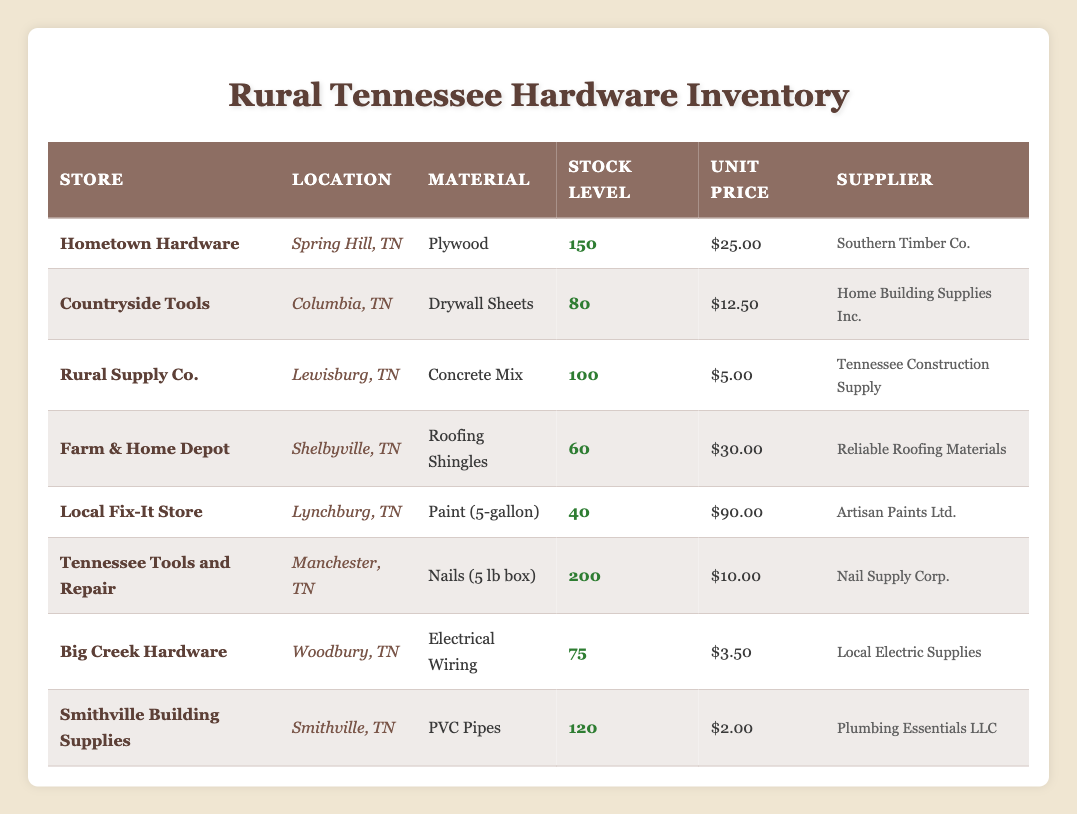What is the stock level of ""Plywood"" at Hometown Hardware? Hometown Hardware has a stock level of 150 for Plywood as listed in the inventory table.
Answer: 150 Which store has the highest stock level of home repair materials? Tennessee Tools and Repair has the highest stock level at 200, for Nails (5 lb box).
Answer: Tennessee Tools and Repair What is the total stock level of Concrete Mix and Drywall Sheets combined? Concrete Mix has a stock level of 100 and Drywall Sheets has a stock level of 80. Adding them gives 100 + 80 = 180.
Answer: 180 Is Local Fix-It Store the supplier for any paint? The Local Fix-It Store sells Paint (5-gallon), which is listed in the inventory. Therefore, the statement is true.
Answer: Yes Which material has the lowest stock level and what is that stock level? Among all materials, Paint (5-gallon) has the lowest stock level at 40.
Answer: 40 How much does it cost to buy the total stock of Electrical Wiring? The stock level for Electrical Wiring is 75 and the unit price is 3.50. The total cost is calculated as 75 * 3.50 = 262.50.
Answer: 262.50 What is the average unit price of all materials available in the inventory? The total cost of all materials is calculated as follows: (25 + 12.50 + 5 + 30 + 90 + 10 + 3.50 + 2) = 178.00. There are 8 materials in total, so the average is 178.00 / 8 = 22.25.
Answer: 22.25 Which supplier provides both Drywall Sheets and PVC Pipes? By examining the supplier column, we see that Drywall Sheets is supplied by Home Building Supplies Inc., and PVC Pipes is supplied by Plumbing Essentials LLC. Therefore, no supplier provides both.
Answer: No How many stores have a stock level greater than 100? The stores with stock levels greater than 100 are Hometown Hardware (150), Tennessee Tools and Repair (200), and Smithville Building Supplies (120). Thus, there are 3 stores.
Answer: 3 